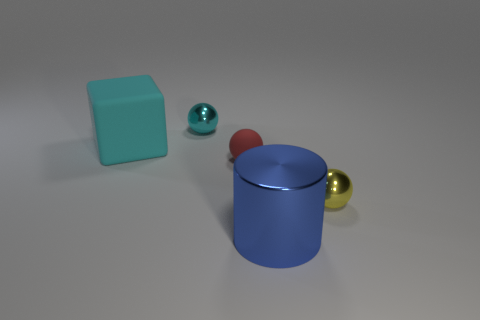Subtract all small cyan spheres. How many spheres are left? 2 Add 3 big cyan cubes. How many objects exist? 8 Subtract all yellow spheres. How many spheres are left? 2 Subtract 2 balls. How many balls are left? 1 Subtract all cylinders. How many objects are left? 4 Subtract all brown cylinders. How many purple spheres are left? 0 Subtract all small gray metallic spheres. Subtract all tiny red rubber objects. How many objects are left? 4 Add 2 cyan metal things. How many cyan metal things are left? 3 Add 2 large matte cubes. How many large matte cubes exist? 3 Subtract 0 gray balls. How many objects are left? 5 